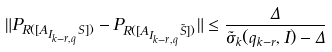Convert formula to latex. <formula><loc_0><loc_0><loc_500><loc_500>\| P _ { R ( [ A _ { I _ { k - r , q } } S ] ) } - P _ { R ( [ A _ { I _ { k - r , q } } \tilde { S } ] ) } \| \leq \frac { \Delta } { \tilde { \sigma } _ { k } ( q _ { k - r } , I ) - \Delta }</formula> 